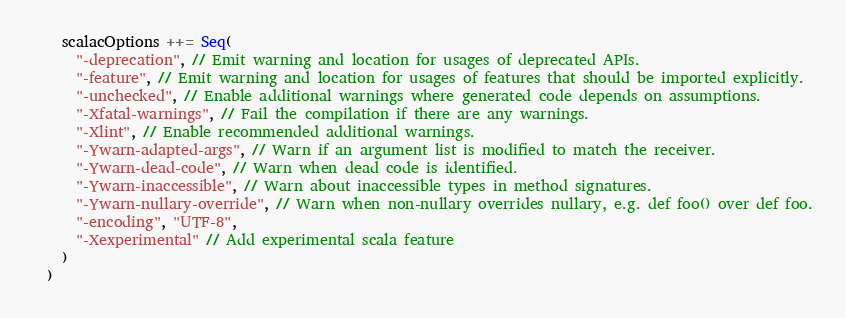Convert code to text. <code><loc_0><loc_0><loc_500><loc_500><_Scala_>    scalacOptions ++= Seq(
      "-deprecation", // Emit warning and location for usages of deprecated APIs.
      "-feature", // Emit warning and location for usages of features that should be imported explicitly.
      "-unchecked", // Enable additional warnings where generated code depends on assumptions.
      "-Xfatal-warnings", // Fail the compilation if there are any warnings.
      "-Xlint", // Enable recommended additional warnings.
      "-Ywarn-adapted-args", // Warn if an argument list is modified to match the receiver.
      "-Ywarn-dead-code", // Warn when dead code is identified.
      "-Ywarn-inaccessible", // Warn about inaccessible types in method signatures.
      "-Ywarn-nullary-override", // Warn when non-nullary overrides nullary, e.g. def foo() over def foo.
      "-encoding", "UTF-8",
      "-Xexperimental" // Add experimental scala feature
    )
  )
</code> 